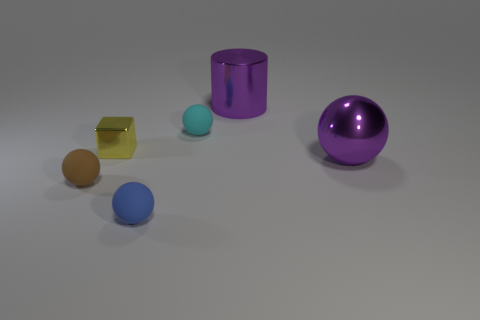There is a brown sphere that is the same size as the yellow metal block; what material is it?
Ensure brevity in your answer.  Rubber. What number of other objects are there of the same material as the blue thing?
Provide a succinct answer. 2. Is the number of brown matte spheres behind the tiny cyan rubber thing less than the number of small brown shiny balls?
Offer a very short reply. No. Does the cyan matte thing have the same shape as the small blue rubber object?
Ensure brevity in your answer.  Yes. What size is the cylinder behind the large purple thing in front of the small ball that is behind the tiny brown thing?
Provide a succinct answer. Large. There is a tiny brown thing that is the same shape as the small blue matte thing; what material is it?
Provide a short and direct response. Rubber. Are there any other things that have the same size as the brown matte sphere?
Your response must be concise. Yes. There is a cyan rubber sphere that is in front of the metal cylinder that is right of the tiny cyan thing; how big is it?
Provide a short and direct response. Small. What is the color of the large sphere?
Ensure brevity in your answer.  Purple. There is a tiny cyan matte sphere behind the brown matte object; how many cyan matte objects are on the right side of it?
Ensure brevity in your answer.  0. 